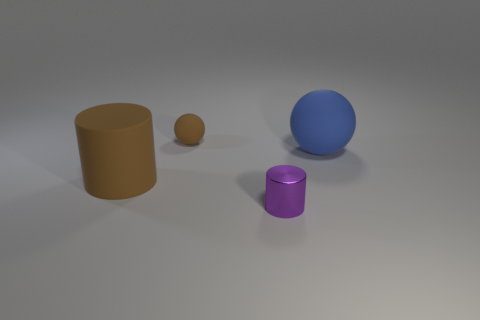Add 2 purple objects. How many objects exist? 6 Subtract all tiny balls. Subtract all tiny rubber balls. How many objects are left? 2 Add 3 metallic objects. How many metallic objects are left? 4 Add 3 small metallic cylinders. How many small metallic cylinders exist? 4 Subtract 0 green balls. How many objects are left? 4 